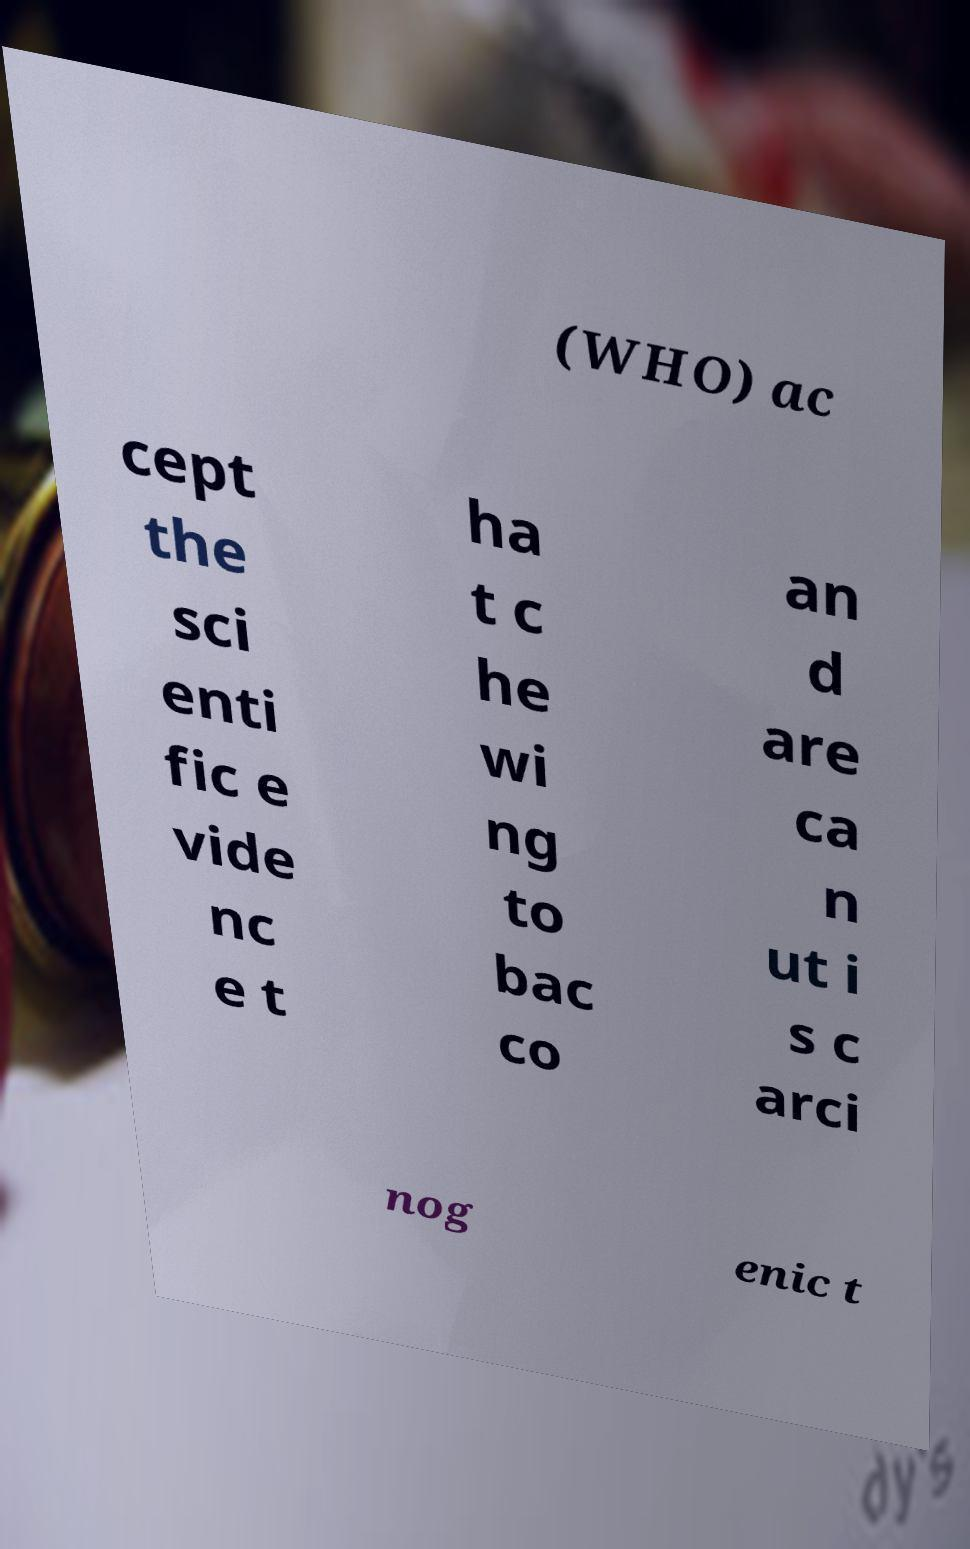There's text embedded in this image that I need extracted. Can you transcribe it verbatim? (WHO) ac cept the sci enti fic e vide nc e t ha t c he wi ng to bac co an d are ca n ut i s c arci nog enic t 